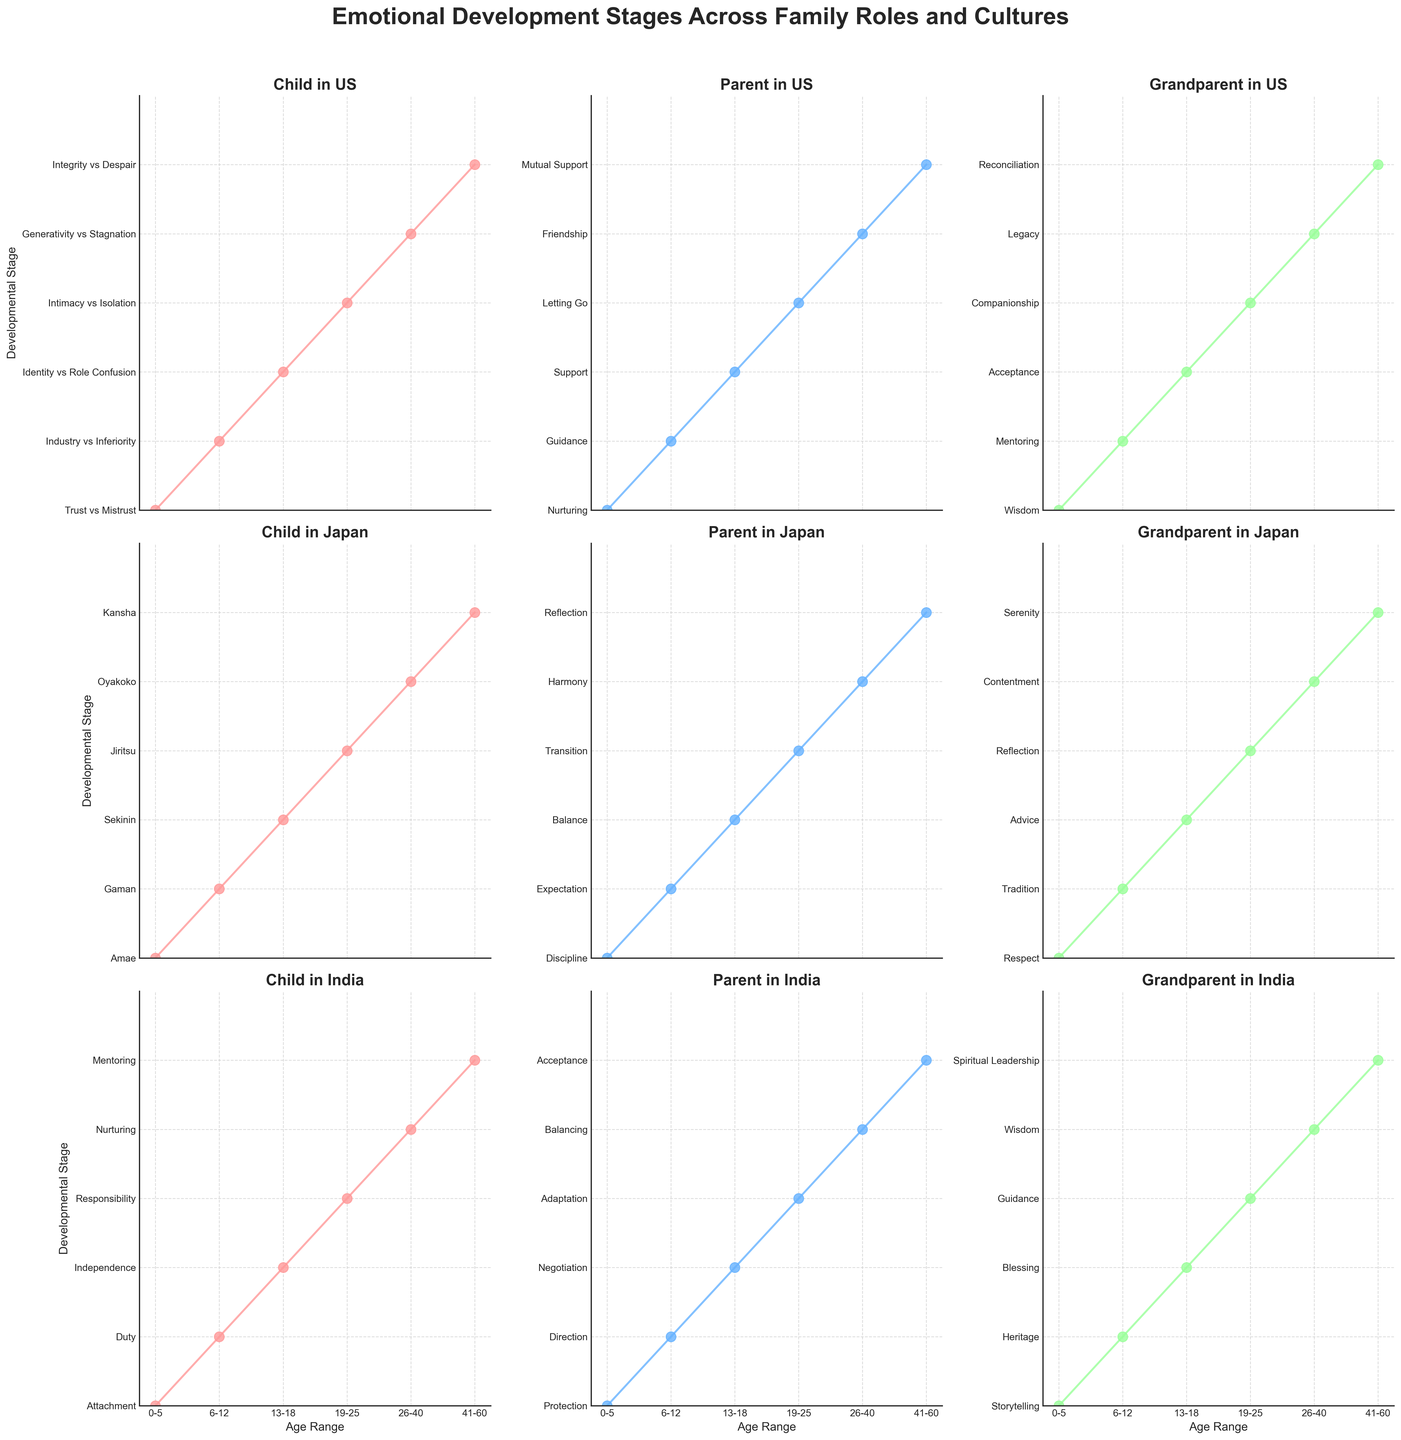What is the title of the figure? The title is located at the top of the figure, usually in a larger and bolder font than the rest of the text.
Answer: Emotional Development Stages Across Family Roles and Cultures How many age ranges are represented in the plot? Count the unique age ranges along the x-axis, which are labeled such as '0-5', '6-12', etc.
Answer: 6 Which culture includes the role of 'Friendship' as a developmental stage? By examining the y-axis labels across different subplots, we can see that 'Friendship' is listed under 'Parent' in the US culture.
Answer: US Between the ages of 0-5, which family role in Japanese culture is associated with 'Amae'? Locate the subplot for 'Child' in Japanese culture, and find the developmental stage listed next to the age '0-5'.
Answer: Child How does the developmental stage for 'Grandparent' differ between the US and Japan for ages 41-60? Compare the y-axis labels for 'Grandparent' in the US and Japan subplots specifically for ages '41-60'. The US lists 'Reconciliation' while Japan lists 'Serenity'.
Answer: US: Reconciliation, Japan: Serenity Which cultural group has 'Integrity vs Despair' marked for 'Parent' role? Check the 'Parent' role across the different subplots and identify which one has 'Integrity vs Despair' listed as a stage.
Answer: None Which role in Indian culture emphasizes 'Spiritual Leadership' at ages 41-60? Look at the subplot for Indian culture and examine the y-axis labels for ages 41-60. It is listed under the 'Grandparent' role.
Answer: Grandparent At what age does the role of 'Acceptance' appear for parents in the Japanese culture? Find the subplot dedicated to Japanese culture for the 'Parent' role and note the y-axis label for 'Acceptance'. It appears at ages 41-60.
Answer: 41-60 What is the developmental stage for 'Child' in Indian culture at ages 13-18? Inspect the subplot for the 'Child' role in Indian culture and look at the developmental stage listed for ages 13-18.
Answer: Independence Which stage appears under 'Support' for parents in the US culture across all age ranges? Review the stages listed in the subplot for 'Parent' in US culture. 'Support' appears only at ages 13-18.
Answer: 13-18 How does the development stage for 'Grandparent' roles in Japan differ from India at ages 26-40? Compare the developmental stages listed for the 'Grandparent' roles in the subplots of Japan and India for ages 26-40. Japan lists 'Contentment', while India lists 'Wisdom'.
Answer: Japan: Contentment, India: Wisdom 